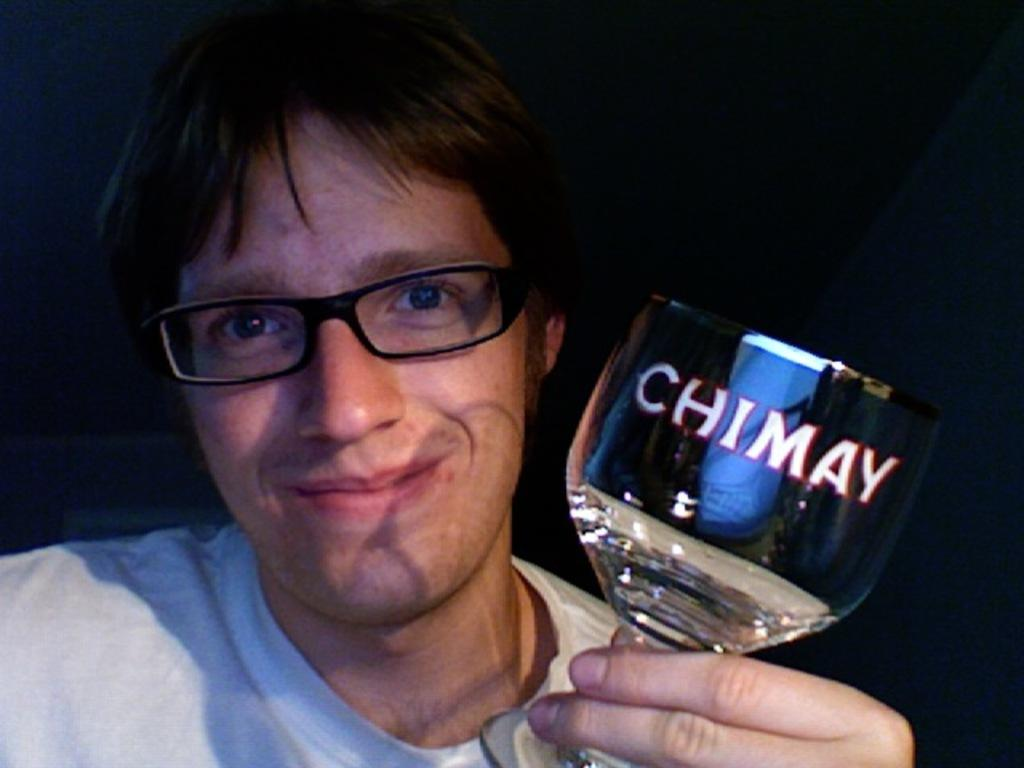What is present in the image? There is a man in the image. What is the man holding in his hand? The man is holding a glass in his hand. What color is the orange that the man is holding in the image? There is no orange present in the image; the man is holding a glass. 